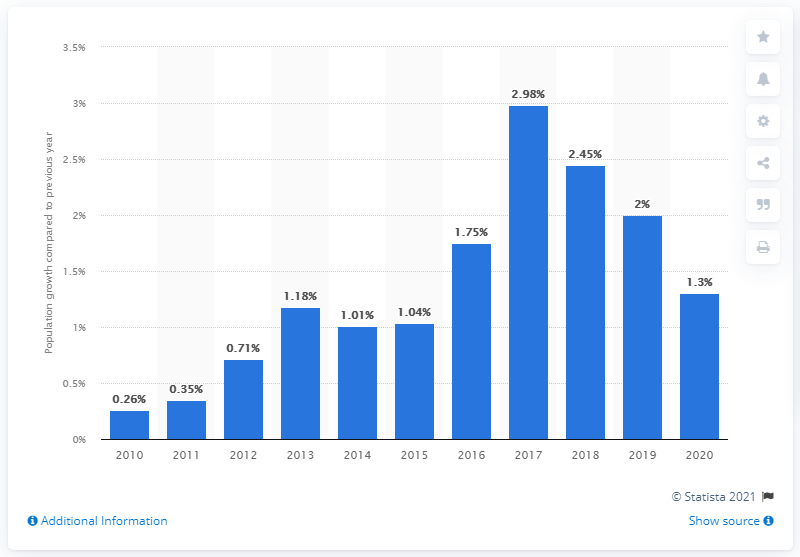Highlight a few significant elements in this photo. The population of Iceland grew by 1.3% in 2020. 